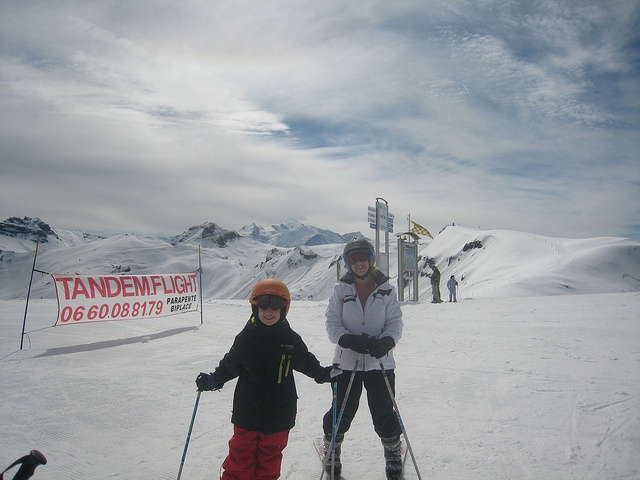Describe the objects in this image and their specific colors. I can see people in gray, black, maroon, and darkgray tones, people in gray, black, and darkgray tones, people in gray and black tones, and people in gray, darkgray, and lightgray tones in this image. 